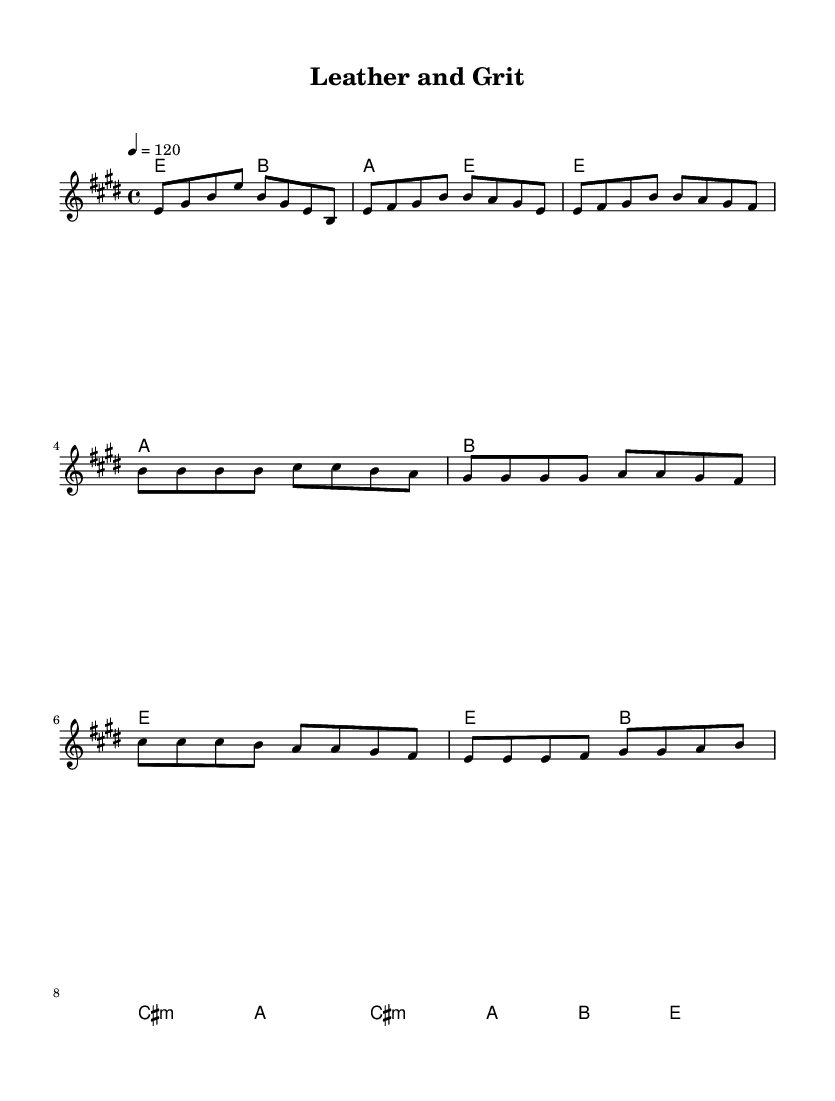What is the key signature of this music? The key signature is E major, which has four sharps: F#, C#, G#, and D#. You can identify the key signature at the beginning of the staff.
Answer: E major What is the time signature of this music? The time signature is 4/4, which is indicated at the beginning of the score, showing that there are four beats in each measure.
Answer: 4/4 What is the tempo marking for this music? The tempo marking is 120 beats per minute, which is indicated with the notation "4 = 120" in the global section.
Answer: 120 How many measures are there in the verse? The verse consists of four measures, which can be counted by looking at the segment labeled as the verse and counting the 4 bar lines.
Answer: 4 What chord follows the first measure of the chorus? The chord that follows the first measure of the chorus is B major, which can be determined from the chord progression listed below the melody.
Answer: B major How many lines are in the lyrics for the chorus? There are four lines in the lyrics for the chorus, as seen from the repeated phrases underneath the three segments of the melody.
Answer: 4 What is the rhythmic pattern of the intro? The rhythmic pattern of the intro is eighth notes followed by quarter notes, which is evident from counting the note values in the first measure of the melody.
Answer: Eighth notes 